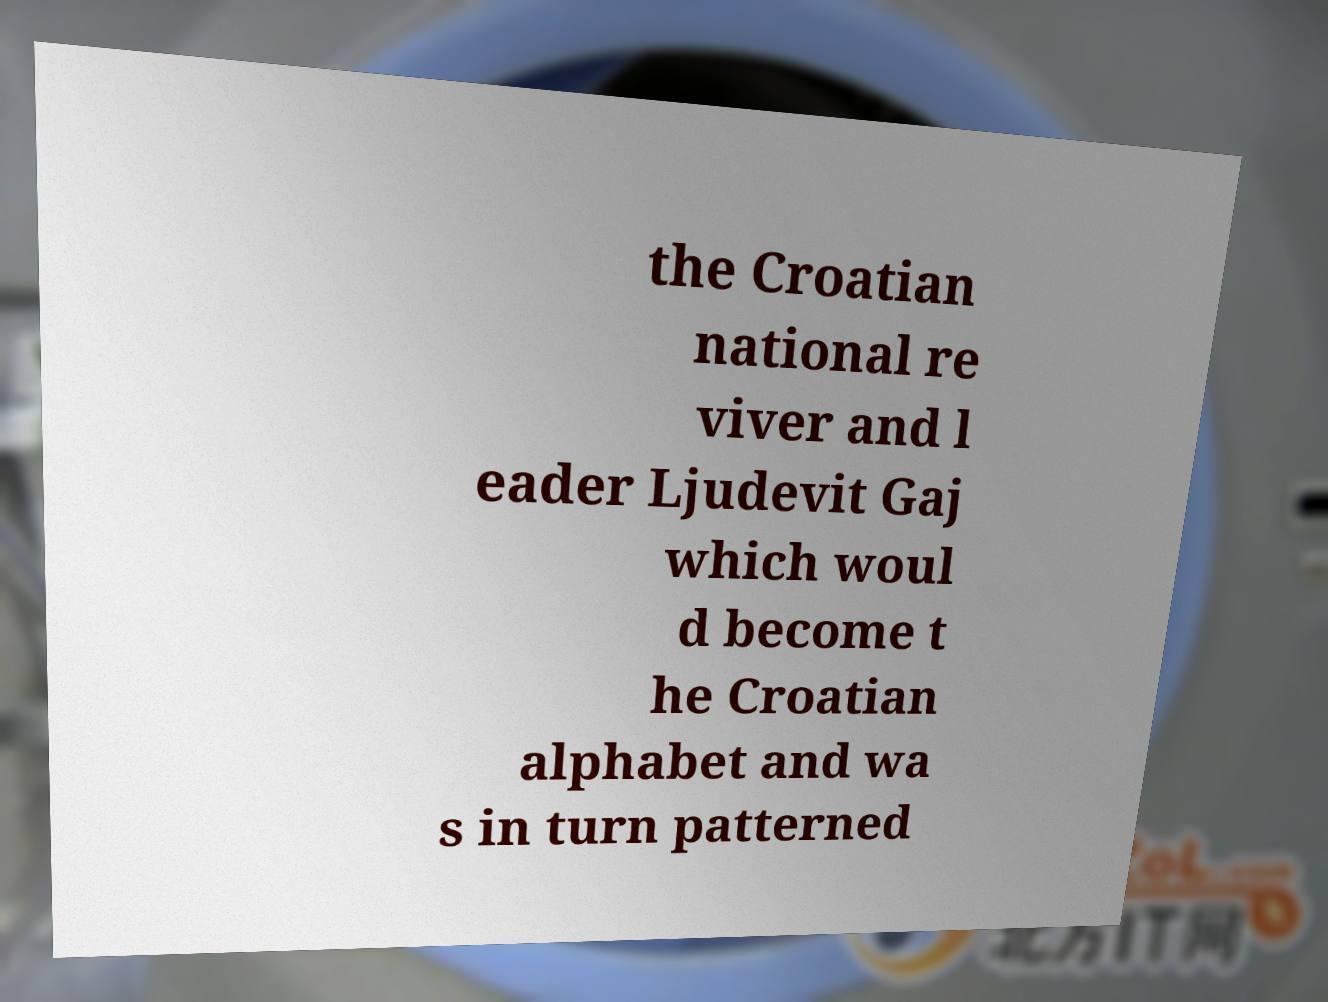Could you assist in decoding the text presented in this image and type it out clearly? the Croatian national re viver and l eader Ljudevit Gaj which woul d become t he Croatian alphabet and wa s in turn patterned 